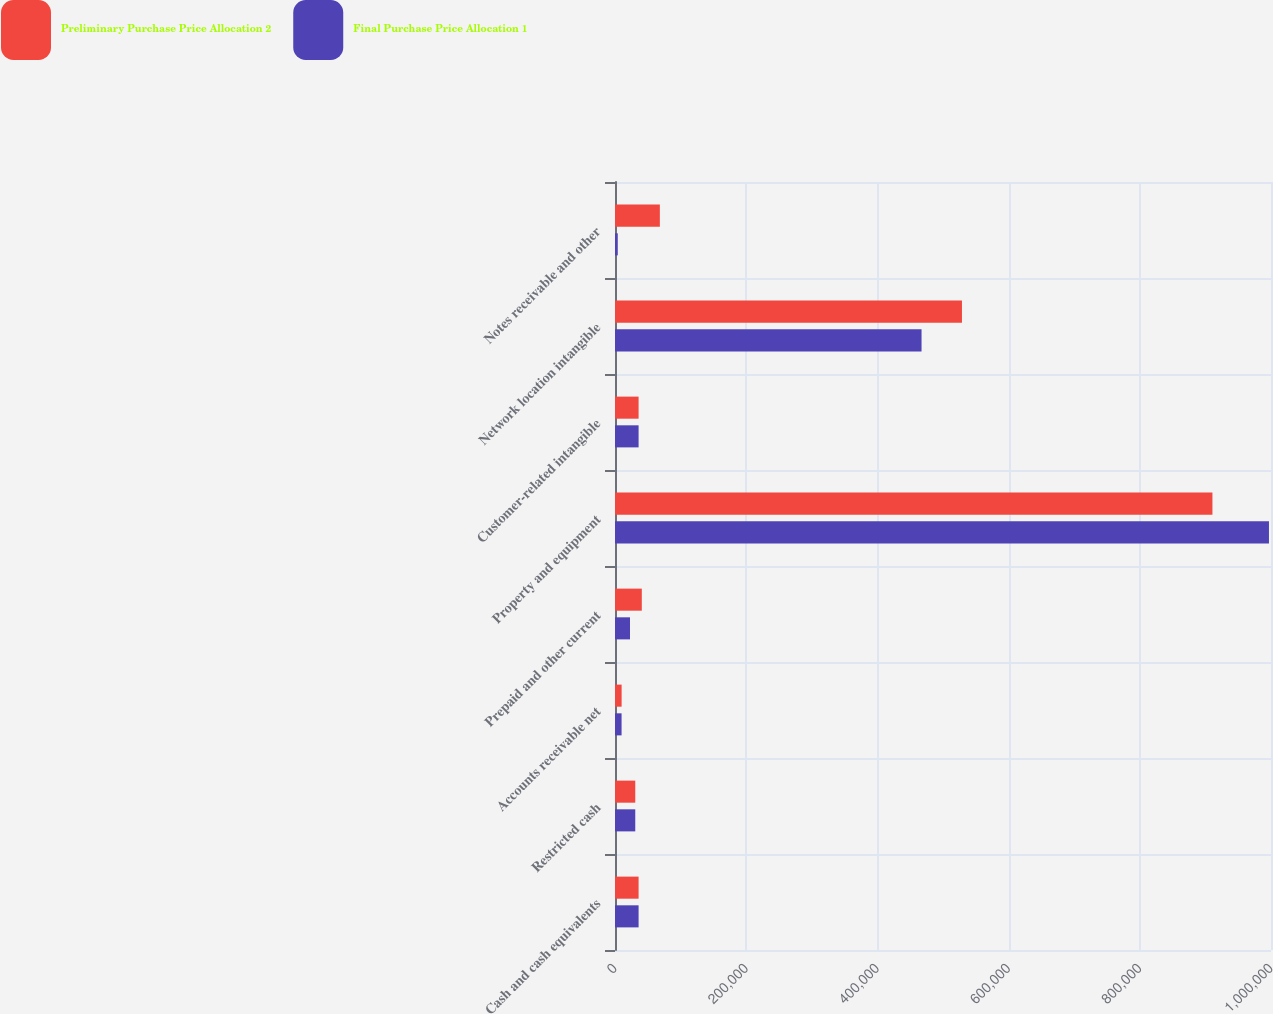<chart> <loc_0><loc_0><loc_500><loc_500><stacked_bar_chart><ecel><fcel>Cash and cash equivalents<fcel>Restricted cash<fcel>Accounts receivable net<fcel>Prepaid and other current<fcel>Property and equipment<fcel>Customer-related intangible<fcel>Network location intangible<fcel>Notes receivable and other<nl><fcel>Preliminary Purchase Price Allocation 2<fcel>35967<fcel>30883<fcel>10102<fcel>40865<fcel>910713<fcel>35967<fcel>528900<fcel>68388<nl><fcel>Final Purchase Price Allocation 1<fcel>35967<fcel>30883<fcel>10021<fcel>22875<fcel>996901<fcel>35967<fcel>467300<fcel>4220<nl></chart> 